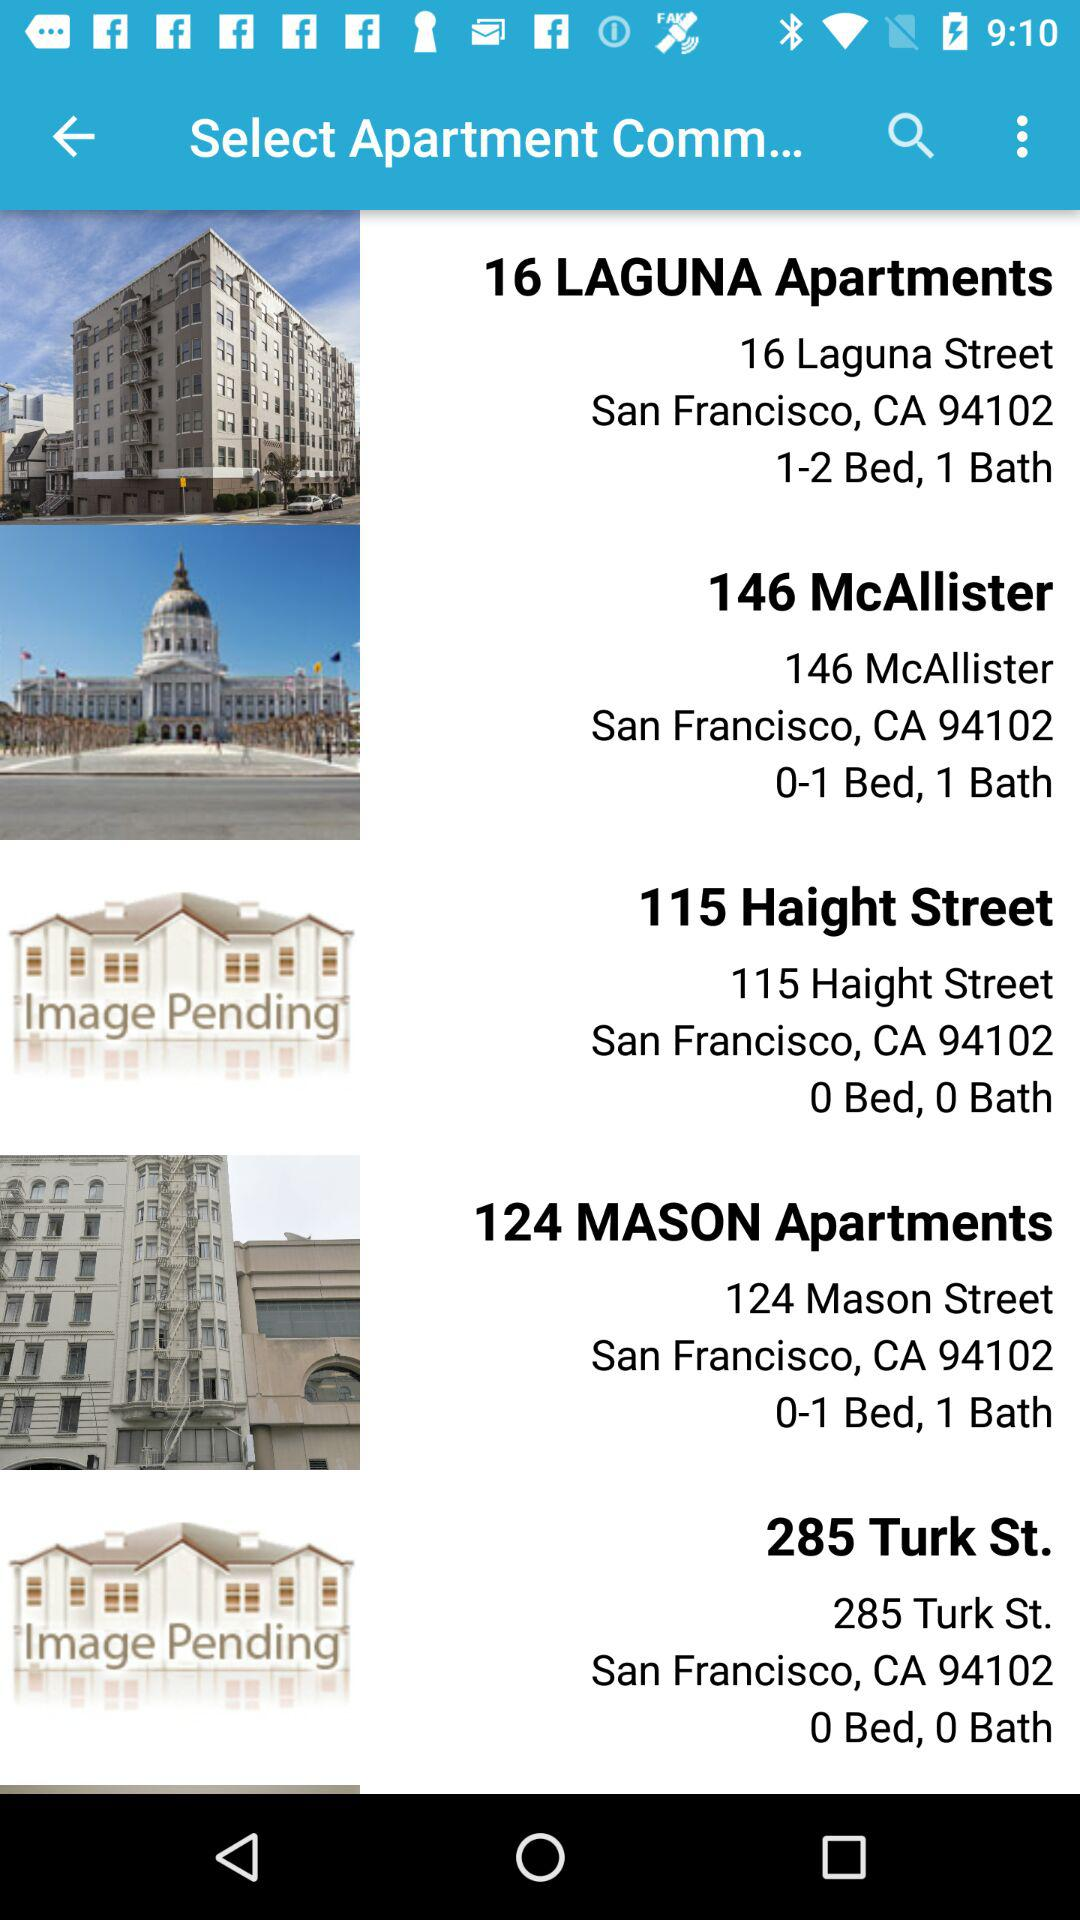How many apartments have 0 beds?
Answer the question using a single word or phrase. 2 